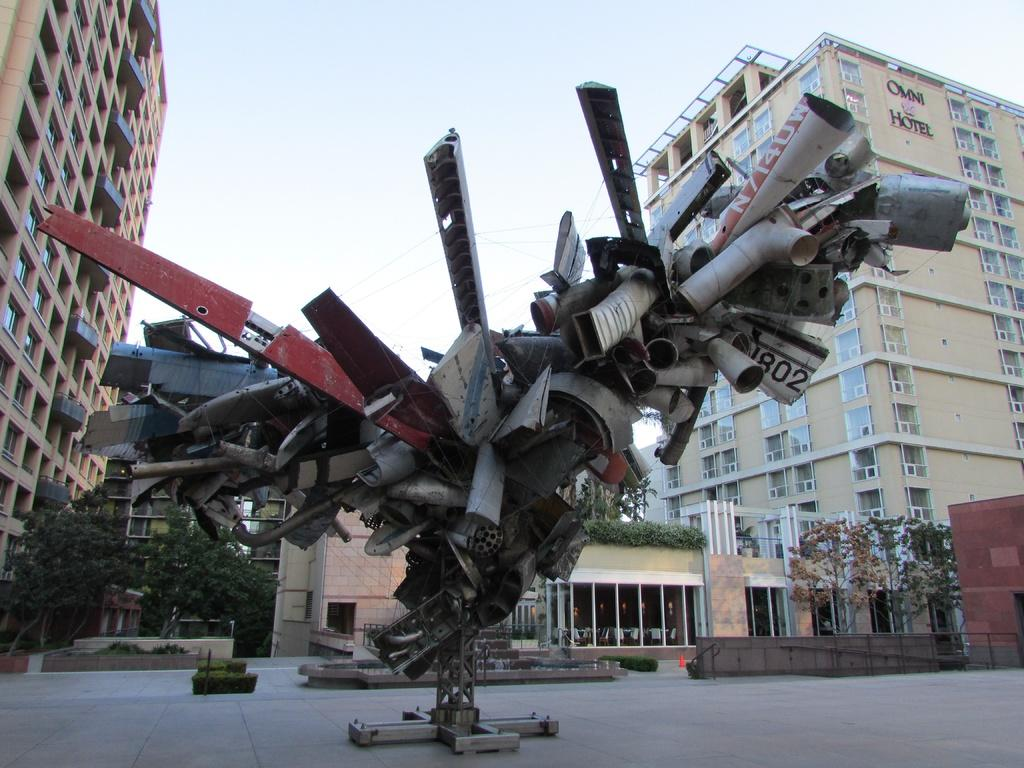What type of objects are located in the front of the image? There are metal objects in the front of the image. What can be seen in the distance behind the metal objects? There are buildings and trees in the background of the image. What type of pies are being served to the friends in the image? There are no pies or friends present in the image; it only features metal objects, buildings, and trees. 